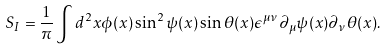<formula> <loc_0><loc_0><loc_500><loc_500>S _ { I } = \frac { 1 } { \pi } \int d ^ { 2 } x \phi ( x ) \sin ^ { 2 } \psi ( x ) \sin \theta ( x ) \epsilon ^ { \mu \nu } \partial _ { \mu } \psi ( x ) \partial _ { \nu } \theta ( x ) .</formula> 